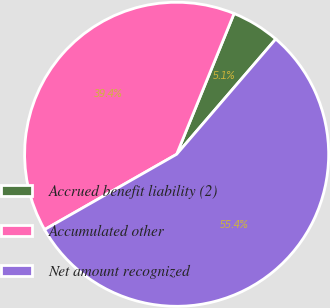<chart> <loc_0><loc_0><loc_500><loc_500><pie_chart><fcel>Accrued benefit liability (2)<fcel>Accumulated other<fcel>Net amount recognized<nl><fcel>5.14%<fcel>39.41%<fcel>55.44%<nl></chart> 